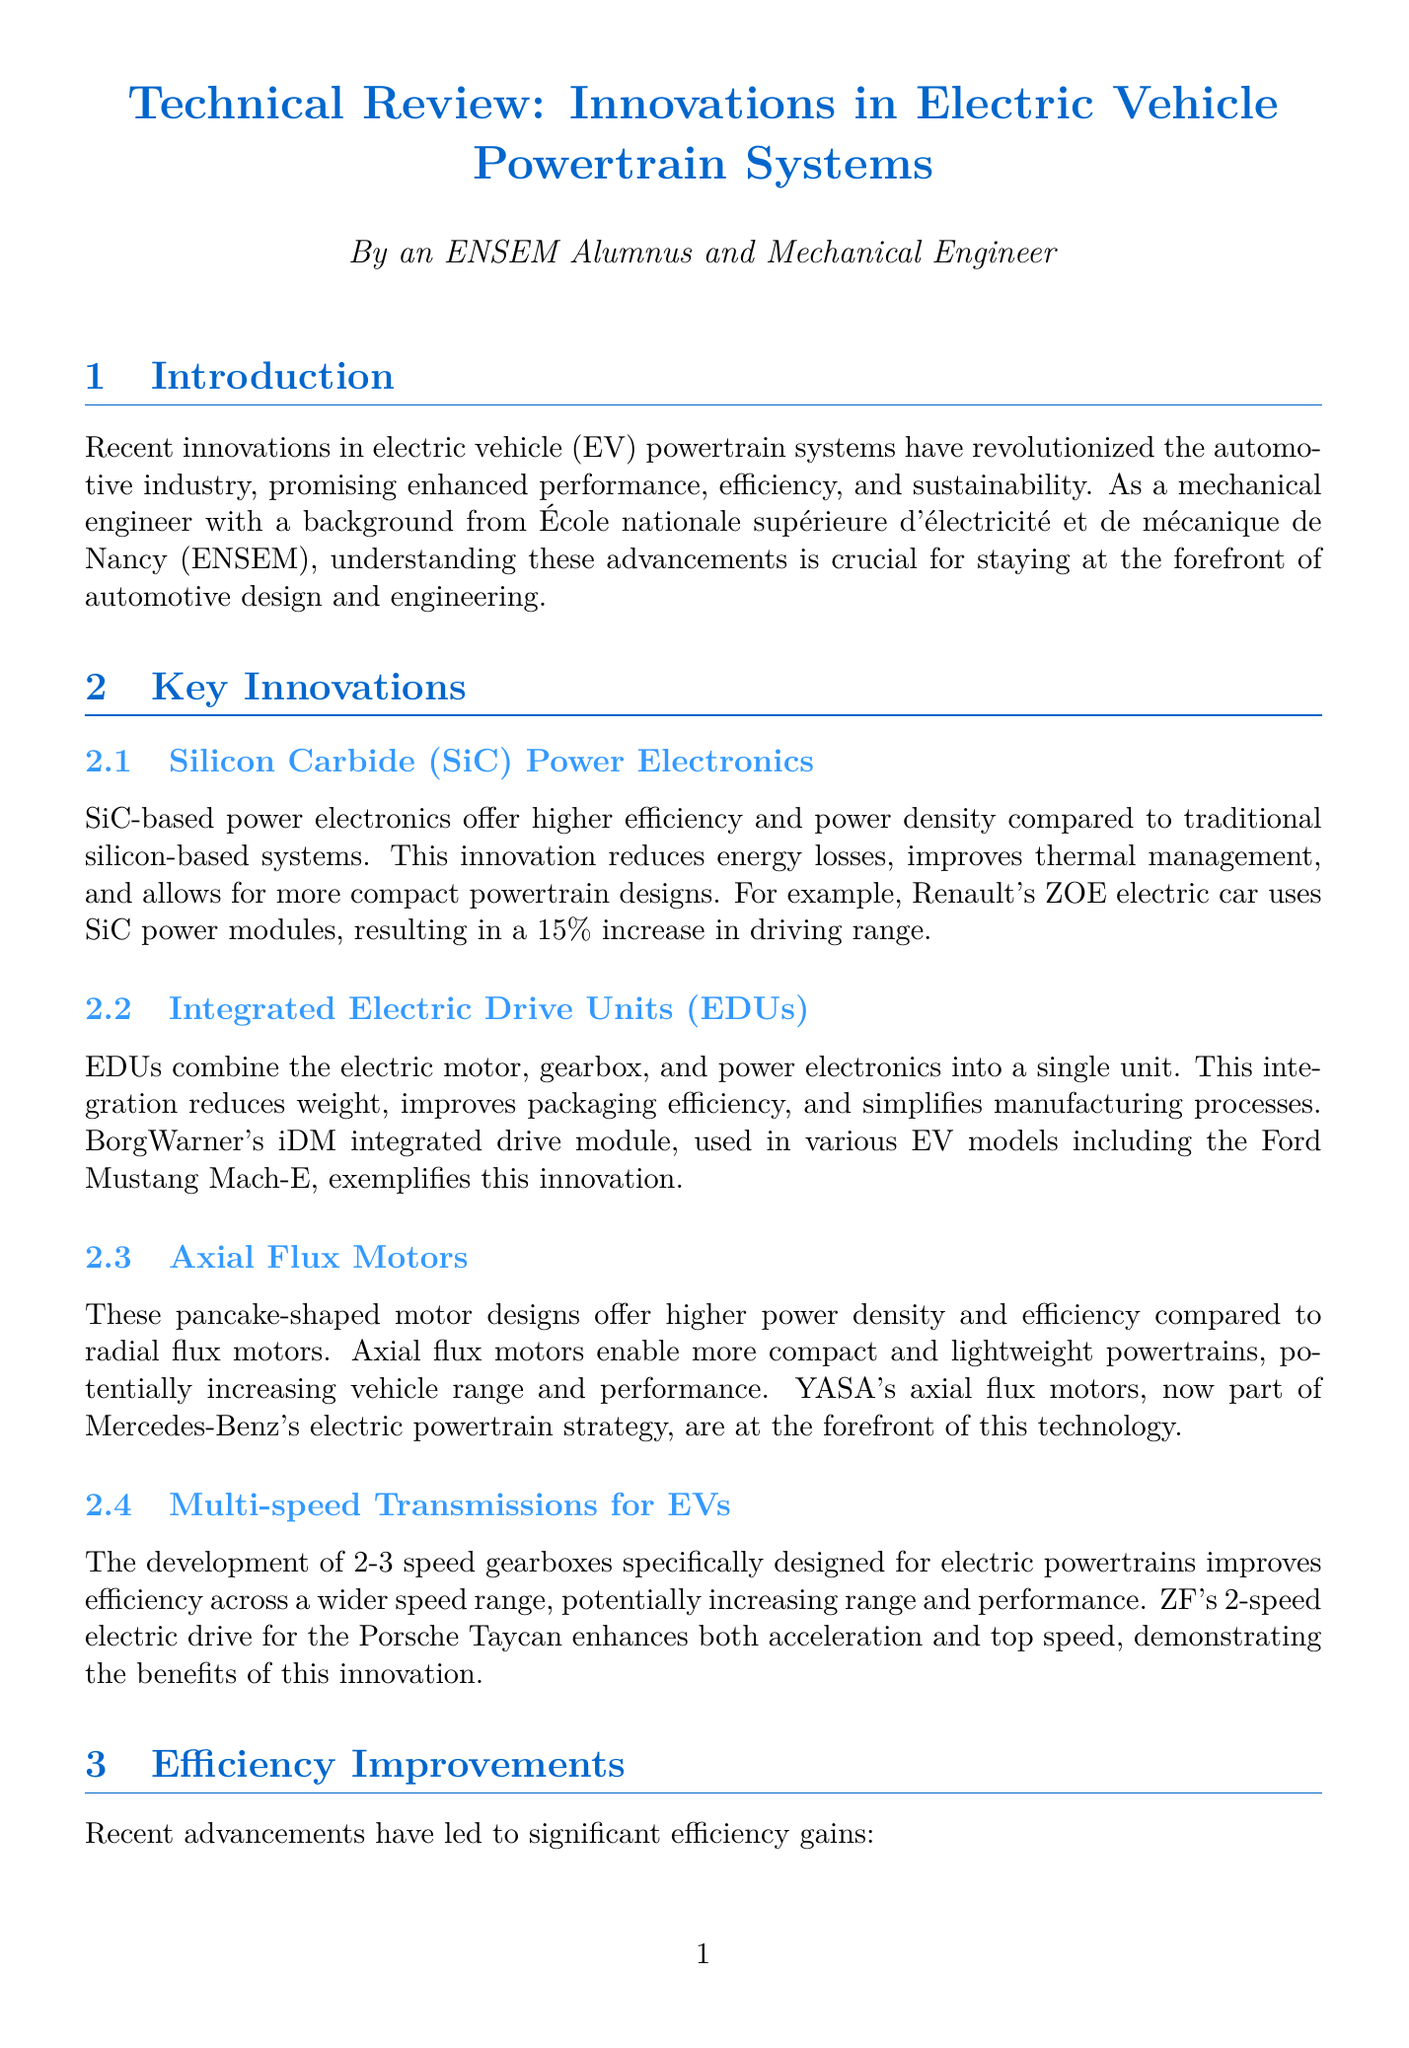What is the main innovation in electric vehicle power electronics? The document states that silicon carbide (SiC) power electronics offer higher efficiency and power density compared to traditional silicon-based systems.
Answer: Silicon Carbide (SiC) Power Electronics What percentage increase in driving range does Renault's ZOE electric car achieve through SiC power modules? The report mentions that Renault's ZOE electric car has a 15% increase in driving range due to the use of SiC power modules.
Answer: 15% What is an example of an integrated electric drive unit mentioned in the document? The document cites BorgWarner's iDM integrated drive module as an example, used in various EV models including the Ford Mustang Mach-E.
Answer: BorgWarner's iDM integrated drive module What efficiency level have recent advancements in motor design and materials reached? The document indicates that motor efficiency has pushed above 97% in some cases.
Answer: Above 97% Which future trend is related to the integration of high-power systems into EV charging? The report discusses the development of wireless charging integration as a future trend for electric vehicles.
Answer: Wireless Charging Integration What is one challenge mentioned regarding the supply chain for electric motors? The document highlights the challenge of securing a stable supply of rare earth materials for electric motors.
Answer: Rare earth materials Which automotive model uses ZF's 2-speed electric drive? The document specifically mentions that ZF's 2-speed electric drive is used in the Porsche Taycan.
Answer: Porsche Taycan What technology is used to optimize power distribution in EVs according to future trends? The report explains that AI-optimized power management is used for optimizing power distribution and energy recuperation in EVs.
Answer: AI-optimized Power Management 